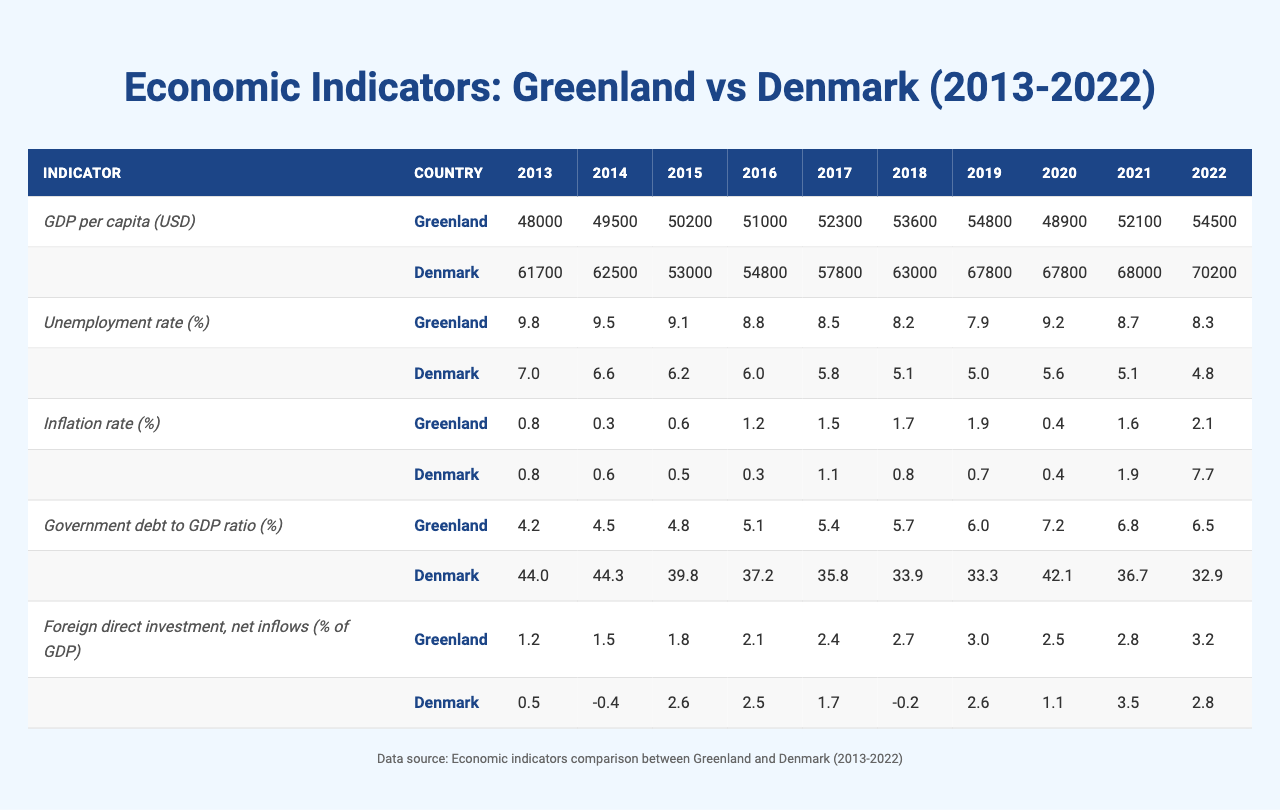What was Greenland's GDP per capita in 2022? In the provided table, the GDP per capita for Greenland in 2022 is listed as 54,500 USD.
Answer: 54,500 USD What was the unemployment rate in Denmark in 2019? The table shows Denmark's unemployment rate in 2019 as 5.0%.
Answer: 5.0% Which country had a higher inflation rate in 2022, Greenland or Denmark? Based on the table, Greenland had an inflation rate of 2.1% in 2022, while Denmark's was 7.7%. Therefore, Denmark had a higher inflation rate.
Answer: Denmark What is the average GDP per capita for Greenland over the last decade? To calculate the average GDP per capita for Greenland from 2013 to 2022, add all the GDP figures for each year (48,000 + 49,500 + 50,200 + 51,000 + 52,300 + 53,600 + 54,800 + 48,900 + 52,100 + 54,500) = 529,900, then divide by 10. The average is 52,990 USD.
Answer: 52,990 USD In which year did Greenland experience the highest unemployment rate in the last decade? The table indicates that Greenland had the highest unemployment rate of 9.8% in 2013.
Answer: 2013 What was the change in the government debt to GDP ratio for Denmark from 2013 to 2022? Denmark's government debt to GDP ratio was 44.0% in 2013 and decreased to 32.9% in 2022. The change is calculated as 44.0% - 32.9% = 11.1%.
Answer: 11.1% Did Greenland have a consistent increase in foreign direct investment net inflows over the decade? By examining the table, we see that Greenland's net inflows increased from 1.2% of GDP in 2013 to 3.2% in 2022, indicating a consistent increase.
Answer: Yes What was the average unemployment rate in Denmark over the last decade? The average unemployment rate for Denmark from 2013 to 2022 can be calculated by summing the rates (7.0 + 6.6 + 6.2 + 6.0 + 5.8 + 5.1 + 5.0 + 5.6 + 5.1 + 4.8) = 58.2% and dividing by 10 to get an average of 5.82%.
Answer: 5.82% Which country had lower GDP per capita in 2018, Greenland or Denmark? In 2018, Greenland's GDP per capita was 53,600 USD, while Denmark's was 63,000 USD. Therefore, Greenland had lower GDP per capita that year.
Answer: Greenland What was the inflation rate difference between Greenland and Denmark in 2021? Greenland's inflation rate in 2021 was 1.6%, while Denmark's was 1.9%. The difference is calculated as 1.9% - 1.6% = 0.3%.
Answer: 0.3% 